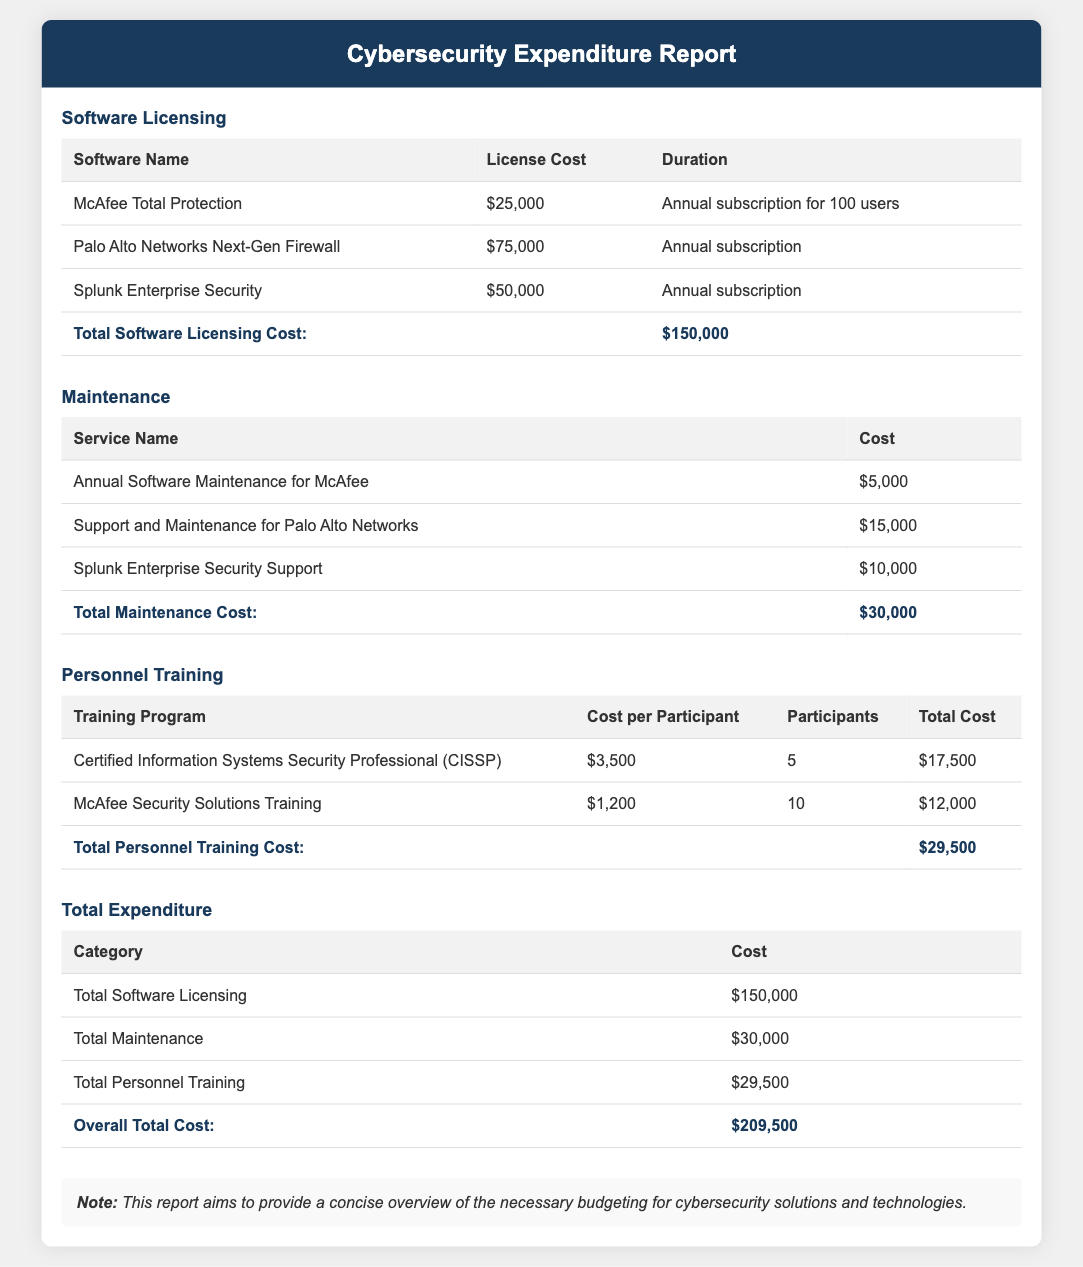What is the total cost of software licensing? The total cost of software licensing is listed in the document under the Software Licensing section, which sums up to $150,000.
Answer: $150,000 What is the maintenance cost for Palo Alto Networks? The maintenance cost for Palo Alto Networks is provided in the Maintenance section of the document, which is $15,000.
Answer: $15,000 How many participants are enrolled in the CISSP training program? The number of participants enrolled in the CISSP training program is specified in the Personnel Training section as 5 participants.
Answer: 5 What is the total expenditure on personnel training? The total expenditure on personnel training is detailed in the document, amounting to $29,500.
Answer: $29,500 What is the overall total cost for all categories? The overall total cost is summarized in the Total Expenditure section, which combines all categories and equals $209,500.
Answer: $209,500 What is the breakdown of the total maintenance cost? The breakdown of the total maintenance cost is given for three services, which adds up to $30,000.
Answer: $30,000 How much does Splunk Enterprise Security cost annually? The annual cost for Splunk Enterprise Security is stated in the Software Licensing section as $50,000.
Answer: $50,000 What note is provided in the document? The note provided at the end of the document indicates that it aims to offer a concise overview of budgeting for cybersecurity solutions and technologies.
Answer: This report aims to provide a concise overview of the necessary budgeting for cybersecurity solutions and technologies 